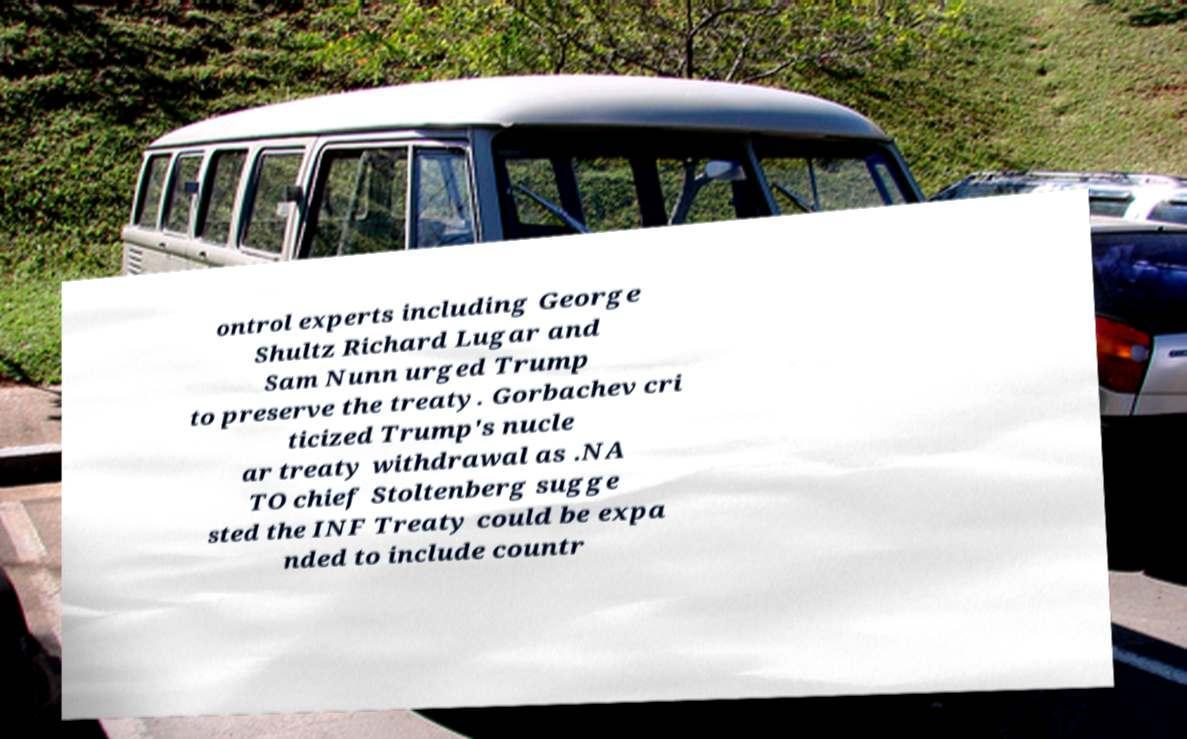I need the written content from this picture converted into text. Can you do that? ontrol experts including George Shultz Richard Lugar and Sam Nunn urged Trump to preserve the treaty. Gorbachev cri ticized Trump's nucle ar treaty withdrawal as .NA TO chief Stoltenberg sugge sted the INF Treaty could be expa nded to include countr 